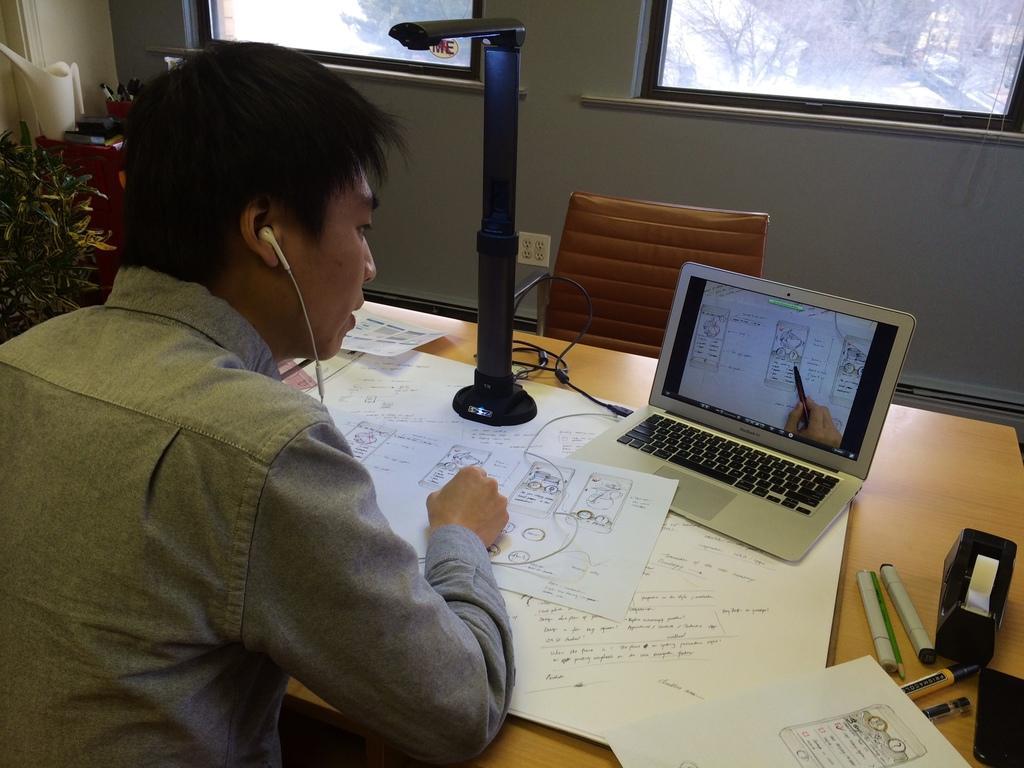Describe this image in one or two sentences. Here a man is listening to the video and writing it on the paper. We can see laptop on the table and pens,marker also. In the background there is a chair,wall and window and a water plant. 